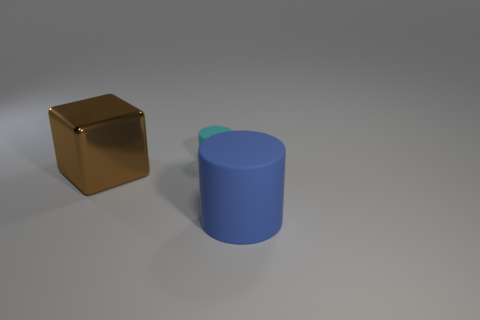Add 3 cyan rubber spheres. How many objects exist? 6 Subtract all blocks. How many objects are left? 2 Subtract all big yellow matte objects. Subtract all blue objects. How many objects are left? 2 Add 3 blue objects. How many blue objects are left? 4 Add 3 large rubber things. How many large rubber things exist? 4 Subtract 0 purple cylinders. How many objects are left? 3 